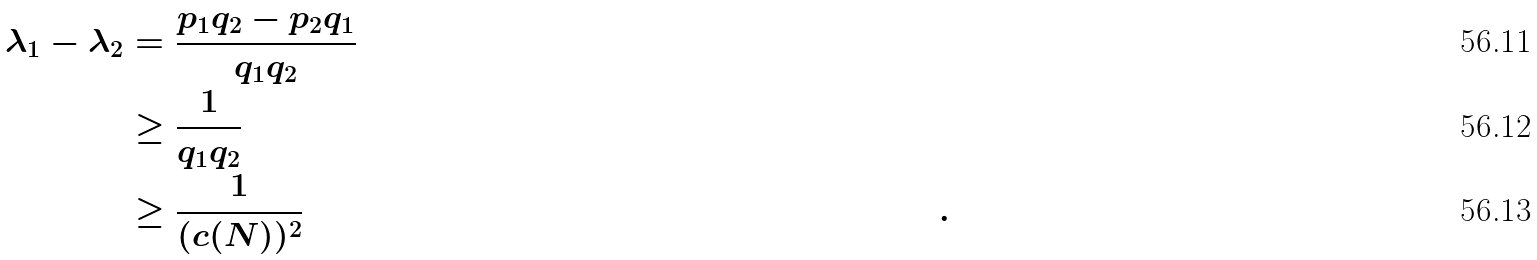<formula> <loc_0><loc_0><loc_500><loc_500>\lambda _ { 1 } - \lambda _ { 2 } & = \frac { p _ { 1 } q _ { 2 } - p _ { 2 } q _ { 1 } } { q _ { 1 } q _ { 2 } } \\ & \geq \frac { 1 } { q _ { 1 } q _ { 2 } } & & \\ & \geq \frac { 1 } { ( c ( N ) ) ^ { 2 } } & & .</formula> 